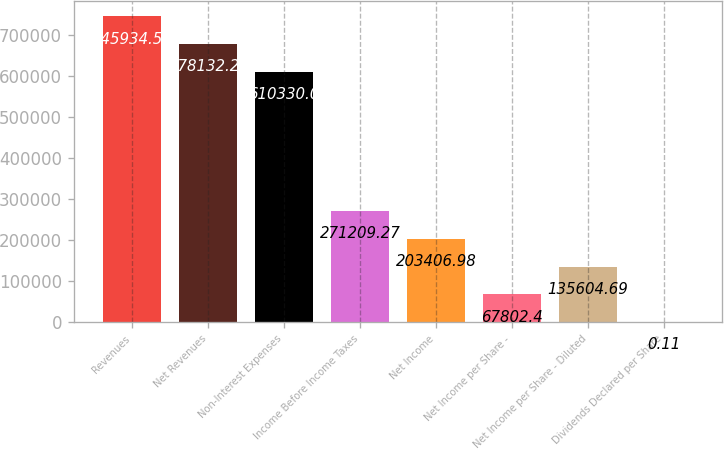<chart> <loc_0><loc_0><loc_500><loc_500><bar_chart><fcel>Revenues<fcel>Net Revenues<fcel>Non-Interest Expenses<fcel>Income Before Income Taxes<fcel>Net Income<fcel>Net Income per Share -<fcel>Net Income per Share - Diluted<fcel>Dividends Declared per Share<nl><fcel>745935<fcel>678132<fcel>610330<fcel>271209<fcel>203407<fcel>67802.4<fcel>135605<fcel>0.11<nl></chart> 